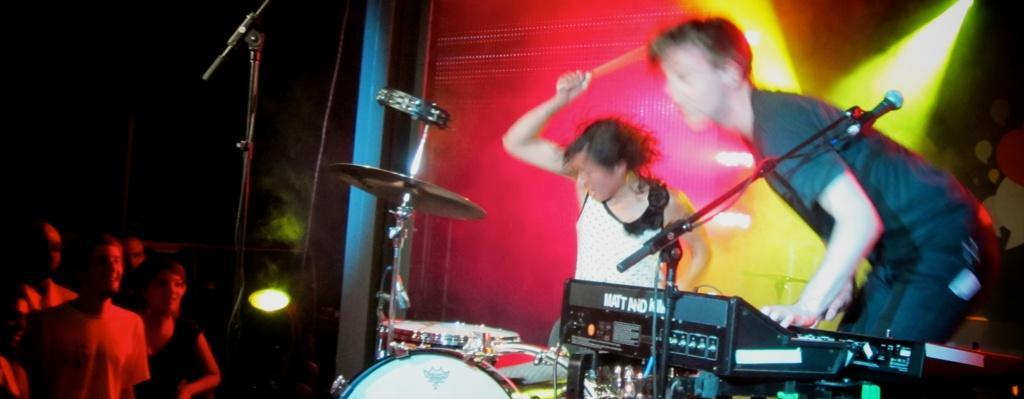Could you give a brief overview of what you see in this image? In this image on the right side there are two people who are playing drums, and there are mikes and some musical instruments and there is a screen and some lights. And on the left side of the image there are some people standing, and there is a mike, trees, light and wires. 